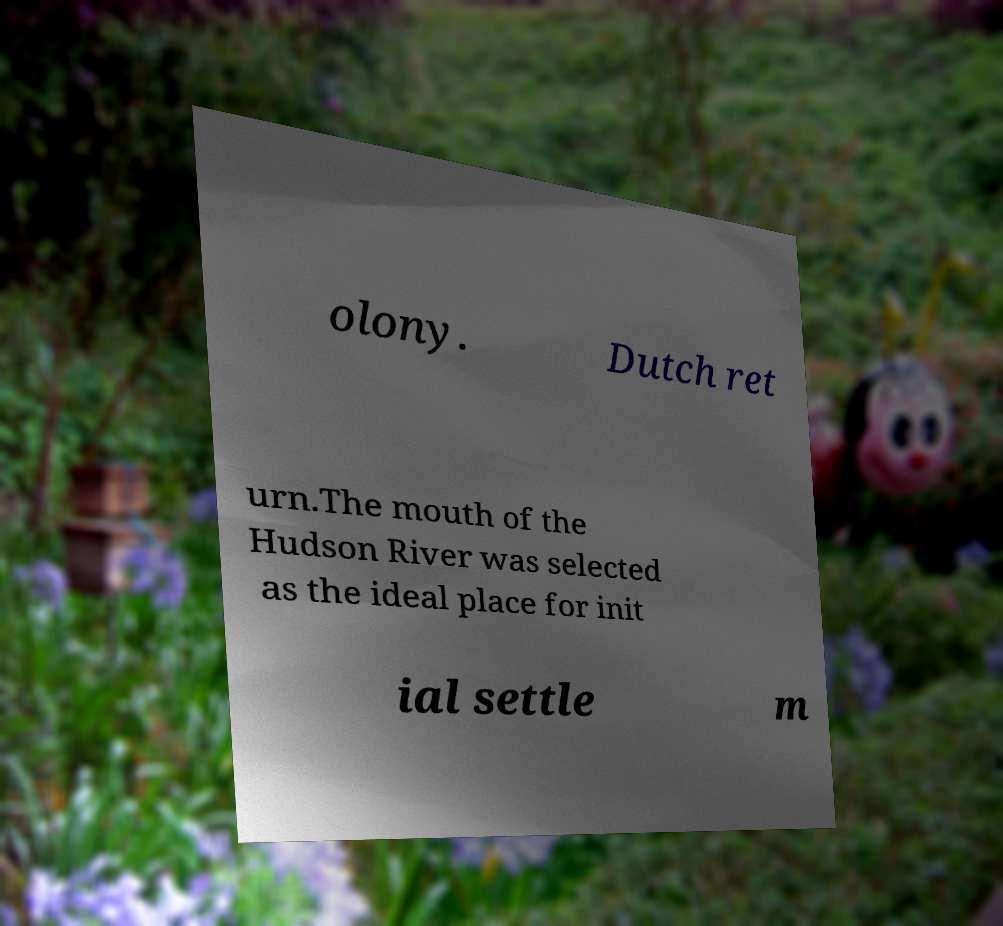There's text embedded in this image that I need extracted. Can you transcribe it verbatim? olony. Dutch ret urn.The mouth of the Hudson River was selected as the ideal place for init ial settle m 